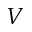Convert formula to latex. <formula><loc_0><loc_0><loc_500><loc_500>V</formula> 